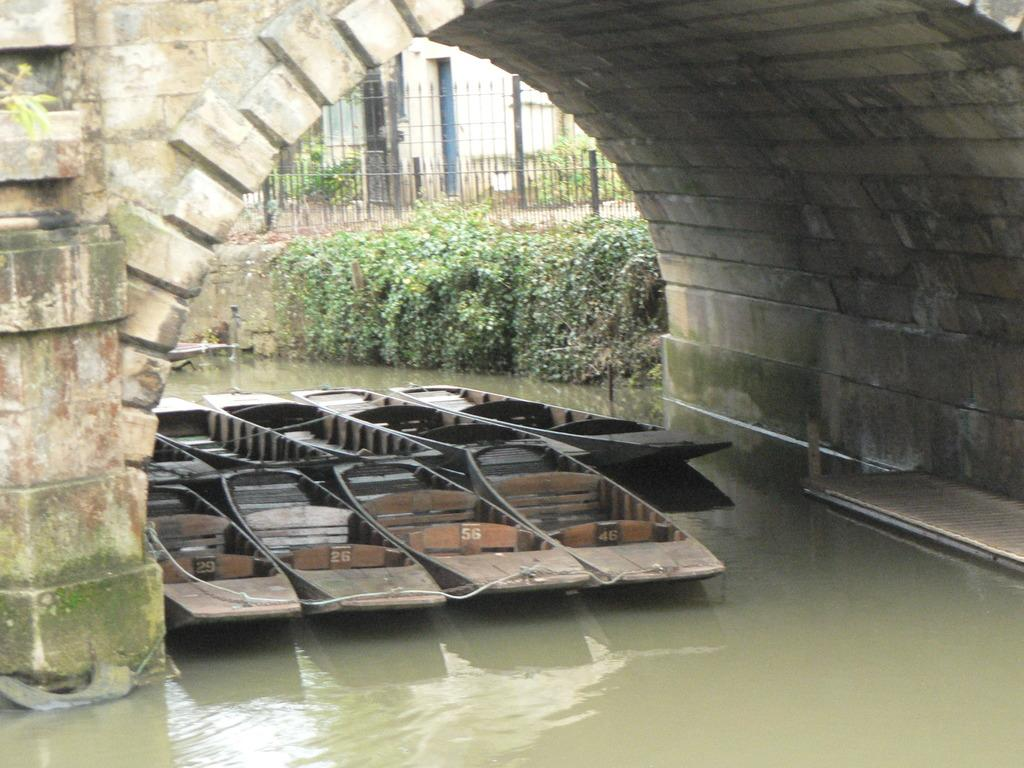What is at the bottom of the image? There is water at the bottom of the image, possibly in a canal. What architectural feature is present in the image? There is an arch in front of the image. What type of vehicles can be seen in the image? Boats are visible in the image. What can be seen in the background of the image? There are trees, a fence, and a building in the background of the image. What type of sponge is being used to clean the boats in the image? There is no sponge visible in the image, and no boats are being cleaned. What time of day is it in the image, considering the presence of a porter? There is no mention of a porter in the image, and the time of day cannot be determined from the provided facts. 